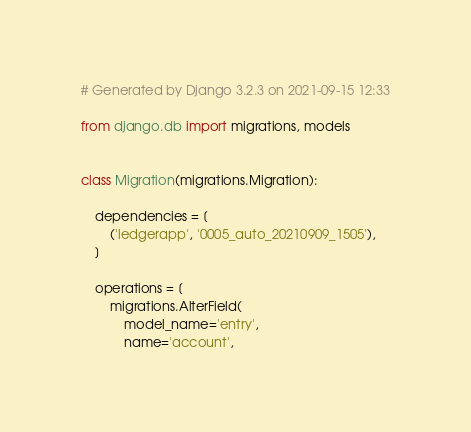Convert code to text. <code><loc_0><loc_0><loc_500><loc_500><_Python_># Generated by Django 3.2.3 on 2021-09-15 12:33

from django.db import migrations, models


class Migration(migrations.Migration):

    dependencies = [
        ('ledgerapp', '0005_auto_20210909_1505'),
    ]

    operations = [
        migrations.AlterField(
            model_name='entry',
            name='account',</code> 